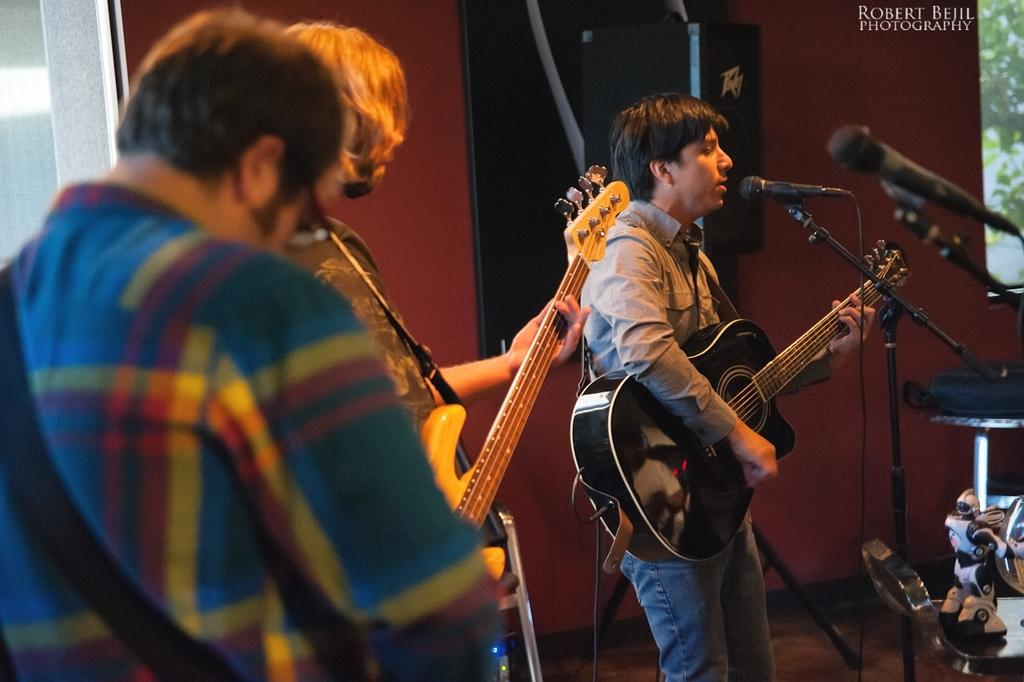How many people are in the image? There are three persons in the image. What are the persons doing in the image? They are playing guitars. What is the color of the wall in the background? There is a red color wall in the background. What other object can be seen in the image? There is a screen in the image. Can you see any toes on the persons playing guitars in the image? There is no specific focus on the toes of the persons in the image, so it cannot be determined if they are visible or not. 